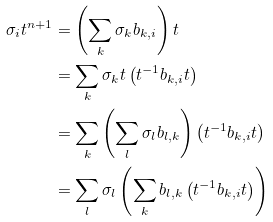Convert formula to latex. <formula><loc_0><loc_0><loc_500><loc_500>\sigma _ { i } t ^ { n + 1 } & = \left ( \sum _ { k } \sigma _ { k } b _ { k , i } \right ) t \\ & = \sum _ { k } \sigma _ { k } t \left ( t ^ { - 1 } b _ { k , i } t \right ) \\ & = \sum _ { k } \left ( \sum _ { l } \sigma _ { l } b _ { l , k } \right ) \left ( t ^ { - 1 } b _ { k , i } t \right ) \\ & = \sum _ { l } \sigma _ { l } \left ( \sum _ { k } b _ { l , k } \left ( t ^ { - 1 } b _ { k , i } t \right ) \right )</formula> 